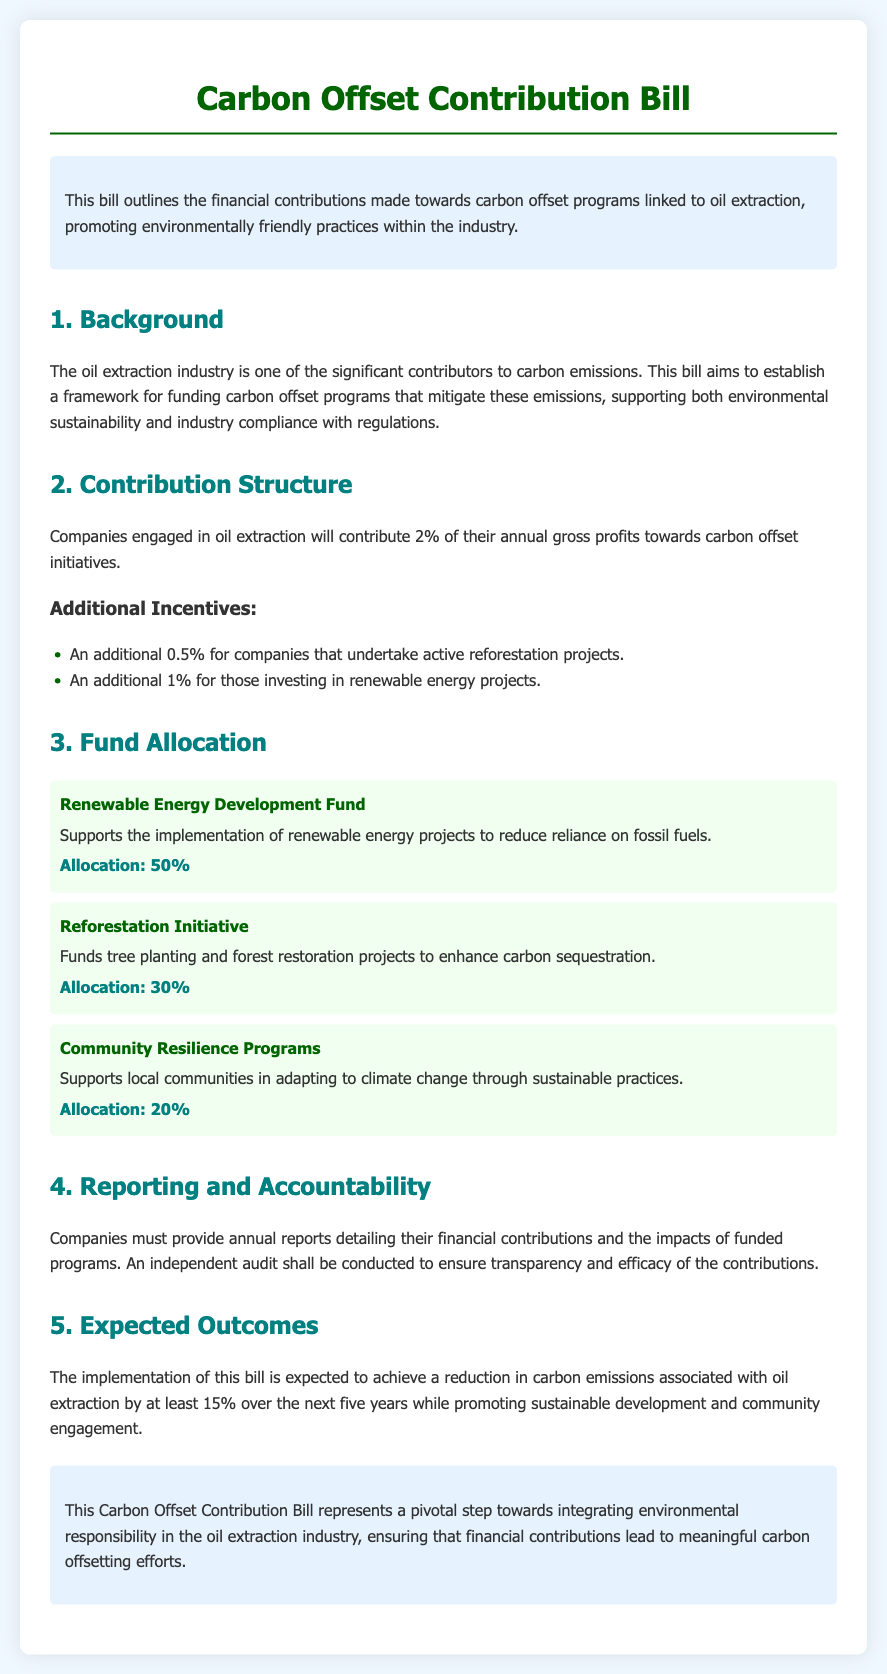What percentage of annual gross profits will companies contribute? The document states that companies engaged in oil extraction will contribute 2% of their annual gross profits towards carbon offset initiatives.
Answer: 2% What is the additional contribution for companies involved in reforestation projects? The bill specifies an additional 0.5% for companies that undertake active reforestation projects.
Answer: 0.5% What is the allocation percentage for the Renewable Energy Development Fund? The document indicates that 50% of the contributions will be allocated to the Renewable Energy Development Fund.
Answer: 50% What is the expected reduction in carbon emissions over the next five years? The bill states that the expected reduction in carbon emissions associated with oil extraction is at least 15% over the next five years.
Answer: 15% What type of programs will companies support according to the Carbon Offset Contribution Bill? The document outlines that companies will support carbon offset initiatives through financial contributions to various programs.
Answer: Carbon offset initiatives 